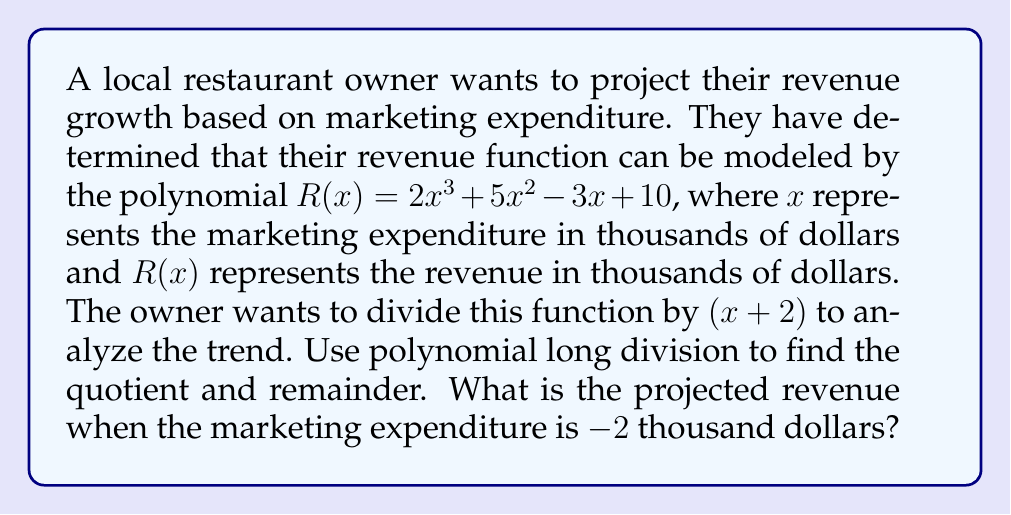Can you solve this math problem? Let's perform polynomial long division of $R(x) = 2x^3 + 5x^2 - 3x + 10$ by $(x + 2)$:

$$
\begin{array}{r}
2x^2 + x - 5 \\
x + 2 \enclose{longdiv}{2x^3 + 5x^2 - 3x + 10} \\
\underline{2x^3 + 4x^2} \\
x^2 - 3x \\
\underline{x^2 + 2x} \\
-5x + 10 \\
\underline{-5x - 10} \\
20
\end{array}
$$

Step 1: Divide $2x^3$ by $x$ to get $2x^2$. Multiply $(x + 2)$ by $2x^2$: $2x^3 + 4x^2$
Step 2: Subtract: $(2x^3 + 5x^2 - 3x + 10) - (2x^3 + 4x^2) = x^2 - 3x + 10$
Step 3: Bring down the next term. Divide $x^2$ by $x$ to get $x$. Multiply $(x + 2)$ by $x$: $x^2 + 2x$
Step 4: Subtract: $(x^2 - 3x + 10) - (x^2 + 2x) = -5x + 10$
Step 5: Bring down the next term. Divide $-5x$ by $x$ to get $-5$. Multiply $(x + 2)$ by $-5$: $-5x - 10$
Step 6: Subtract: $(-5x + 10) - (-5x - 10) = 20$

The quotient is $2x^2 + x - 5$ and the remainder is $20$.

Therefore, $R(x) = (x + 2)(2x^2 + x - 5) + 20$

To find the projected revenue when the marketing expenditure is $-2$ thousand dollars, we substitute $x = -2$ into the original function:

$R(-2) = 2(-2)^3 + 5(-2)^2 - 3(-2) + 10$
$= 2(-8) + 5(4) + 6 + 10$
$= -16 + 20 + 6 + 10$
$= 20$

Alternatively, we can use the remainder directly, as $R(-2)$ is equal to the remainder when $R(x)$ is divided by $(x + 2)$.
Answer: The projected revenue when the marketing expenditure is $-2$ thousand dollars is $20$ thousand dollars. 